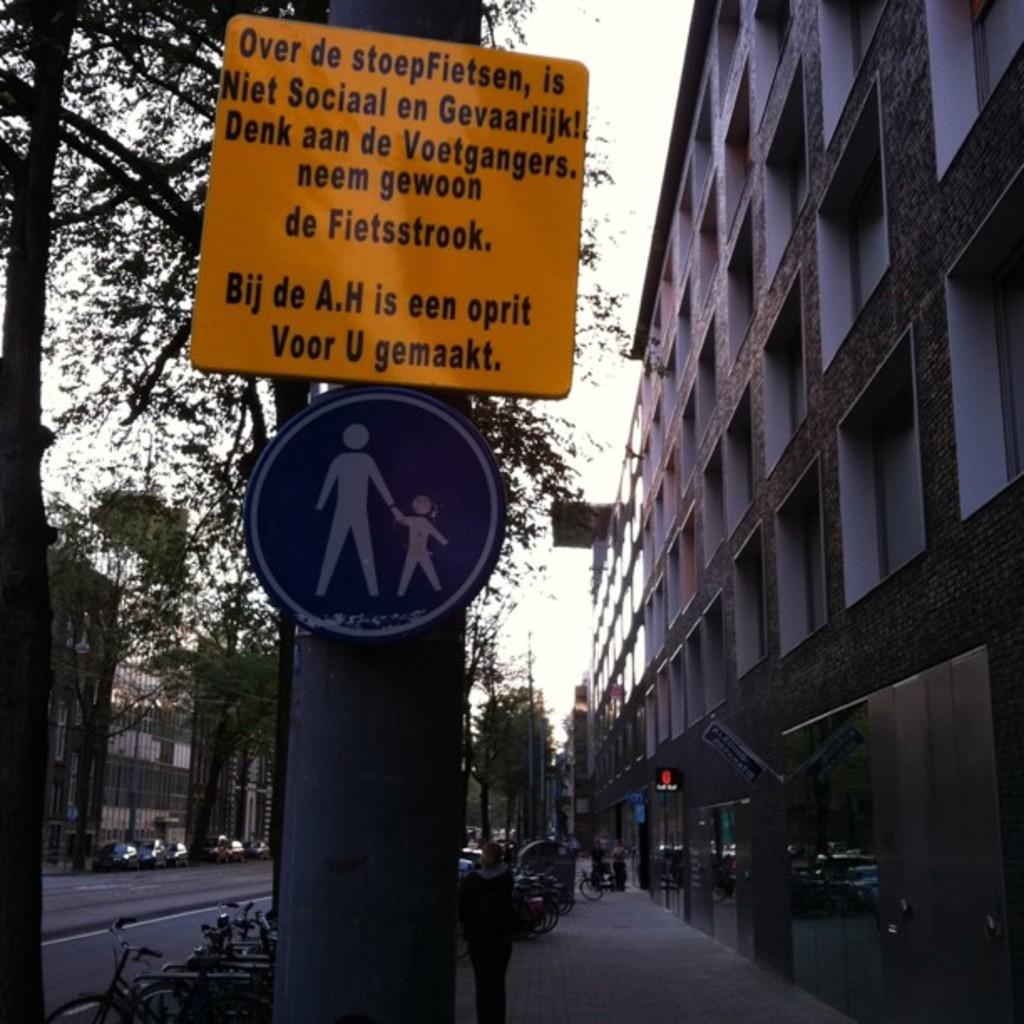What is the first word in the top left of the yellow sign?
Keep it short and to the point. Over. What does the last line on the sign say?
Provide a succinct answer. Voor u gemaakt. 